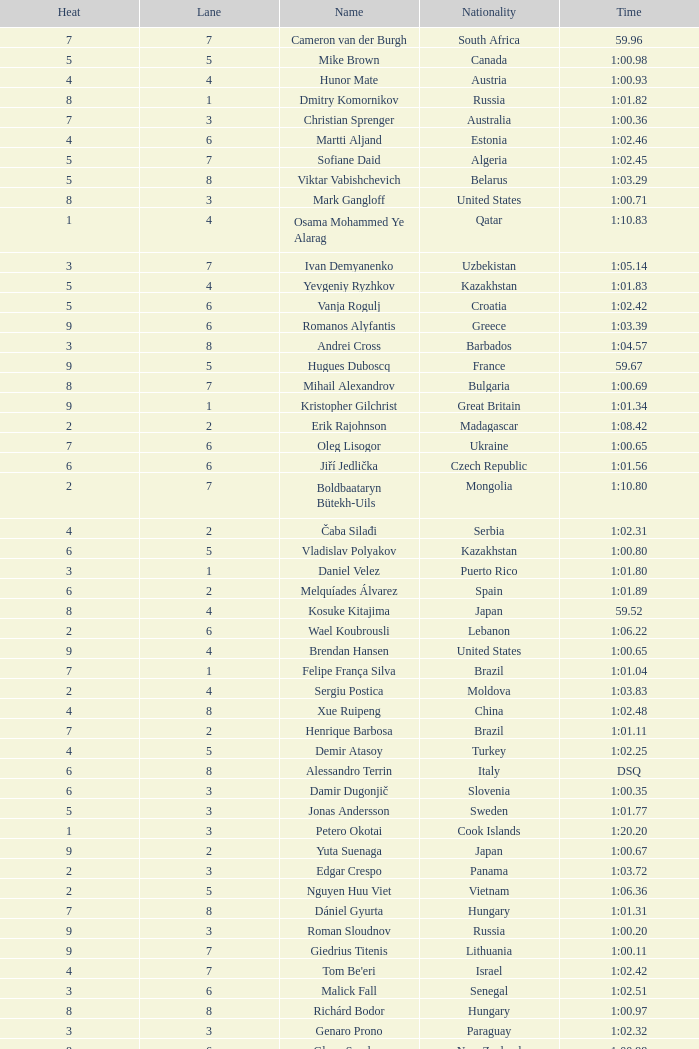What is the smallest lane number of Xue Ruipeng? 8.0. 